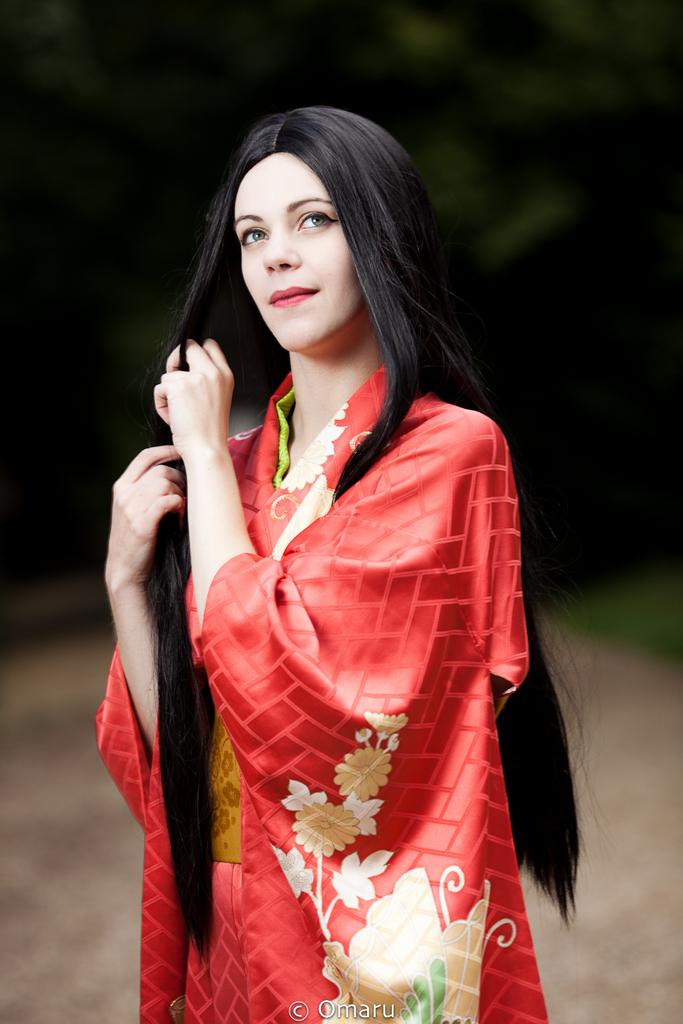What is the main subject of the image? There is a lady person in the image. What is the lady person wearing? The lady person is wearing a red dress. Can you describe the background of the image? The background of the image is blurry. What reward does the lady person receive for wearing a red dress in the image? There is no indication in the image that the lady person is receiving a reward for wearing a red dress. 